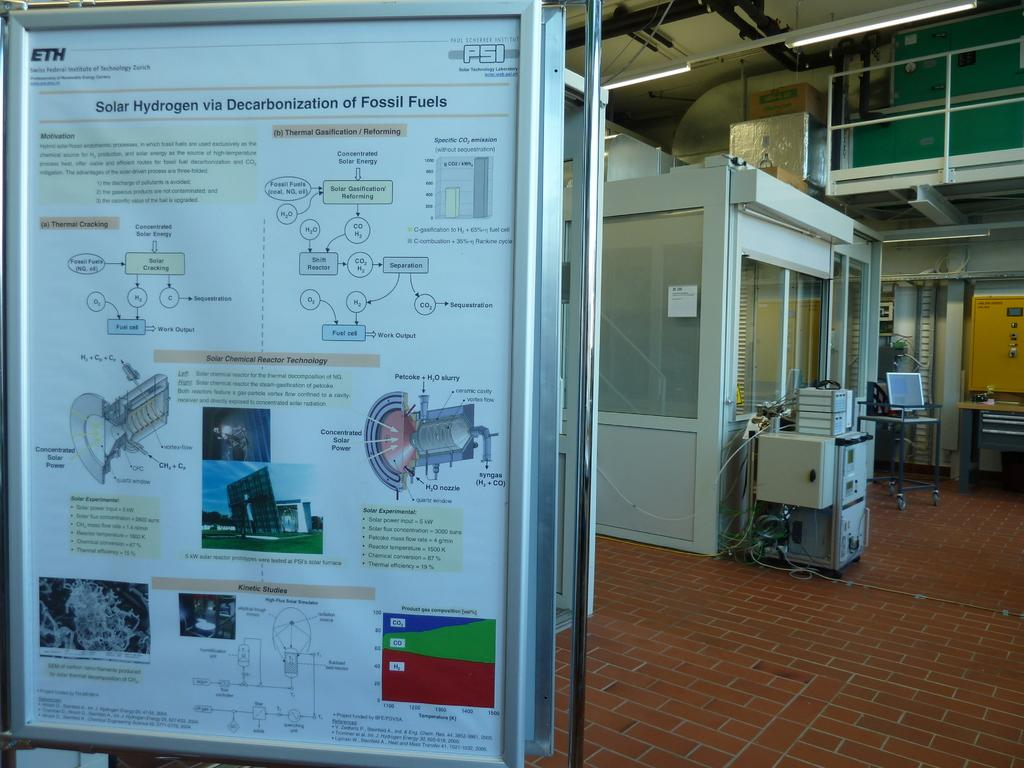<image>
Describe the image concisely. A large visual shows the process of decarbonization in fossil fuels. 